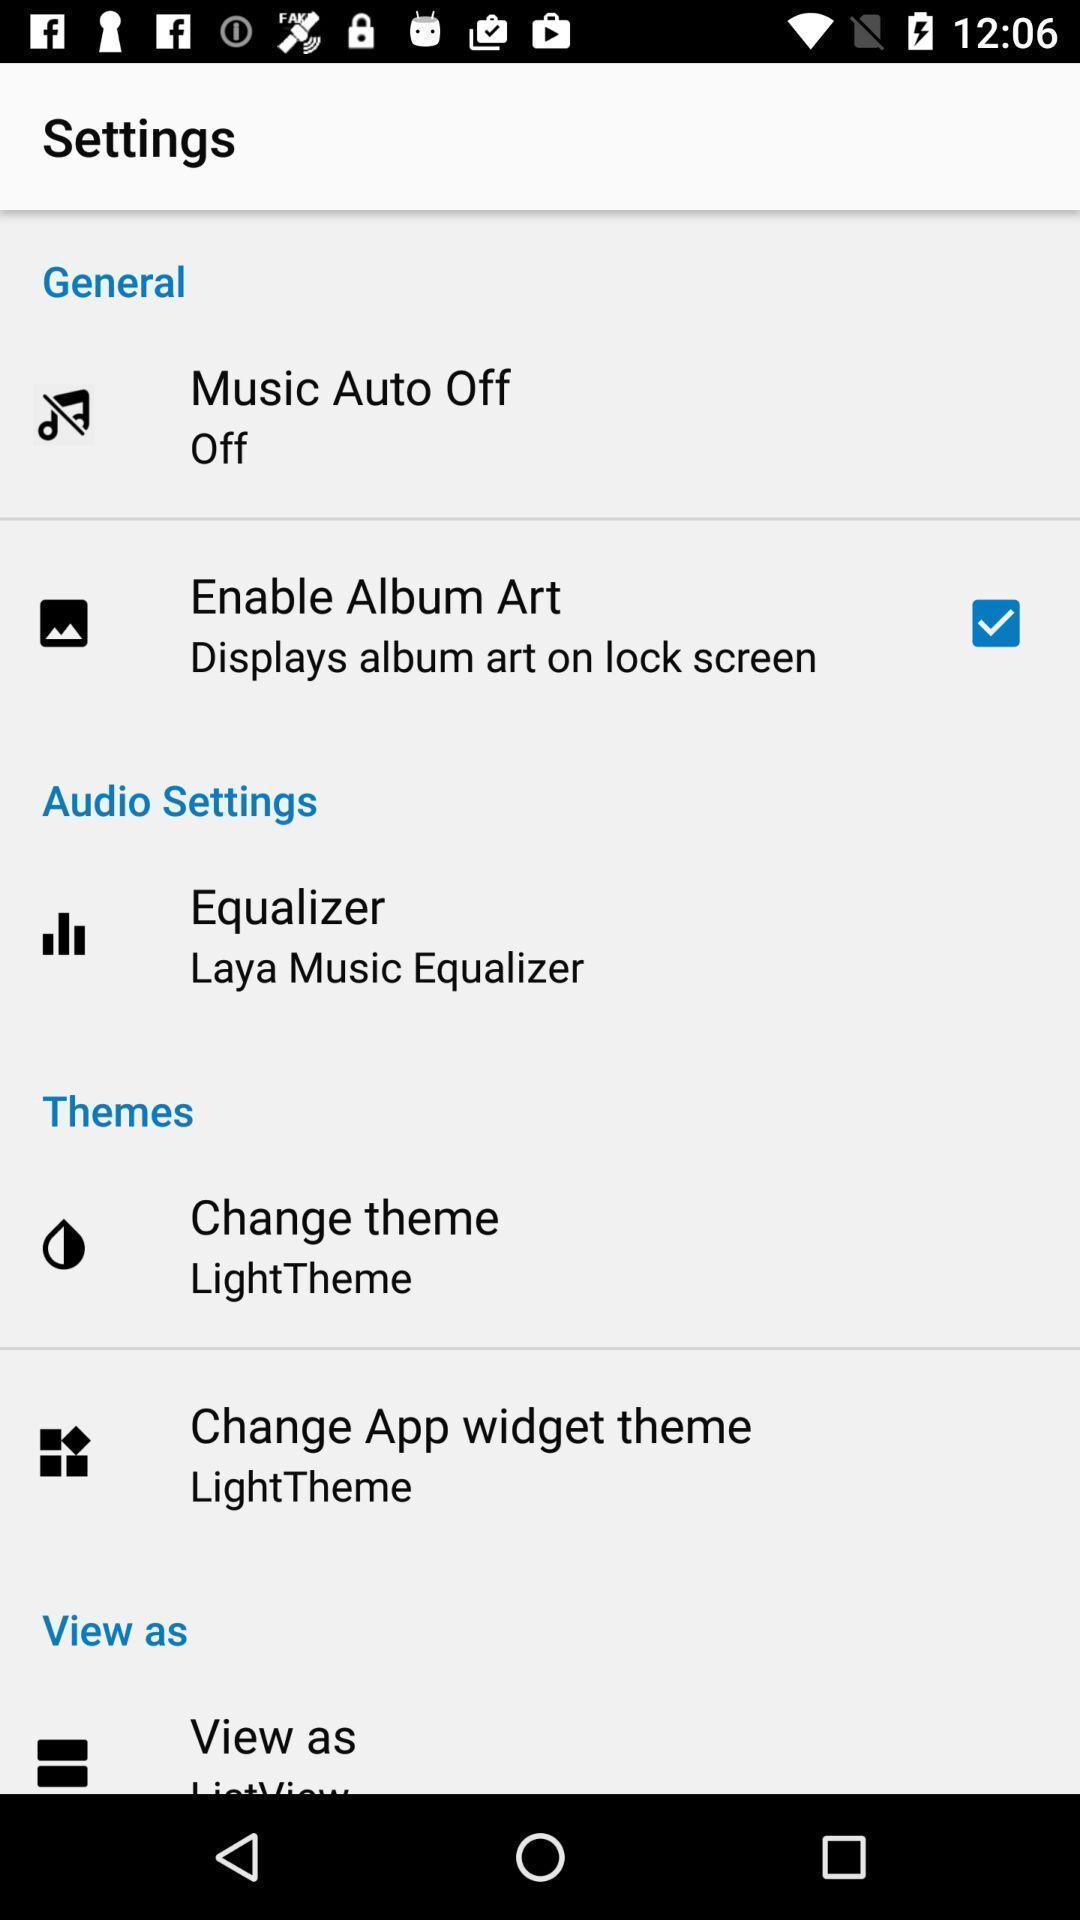Explain what's happening in this screen capture. Settings page with various options. 